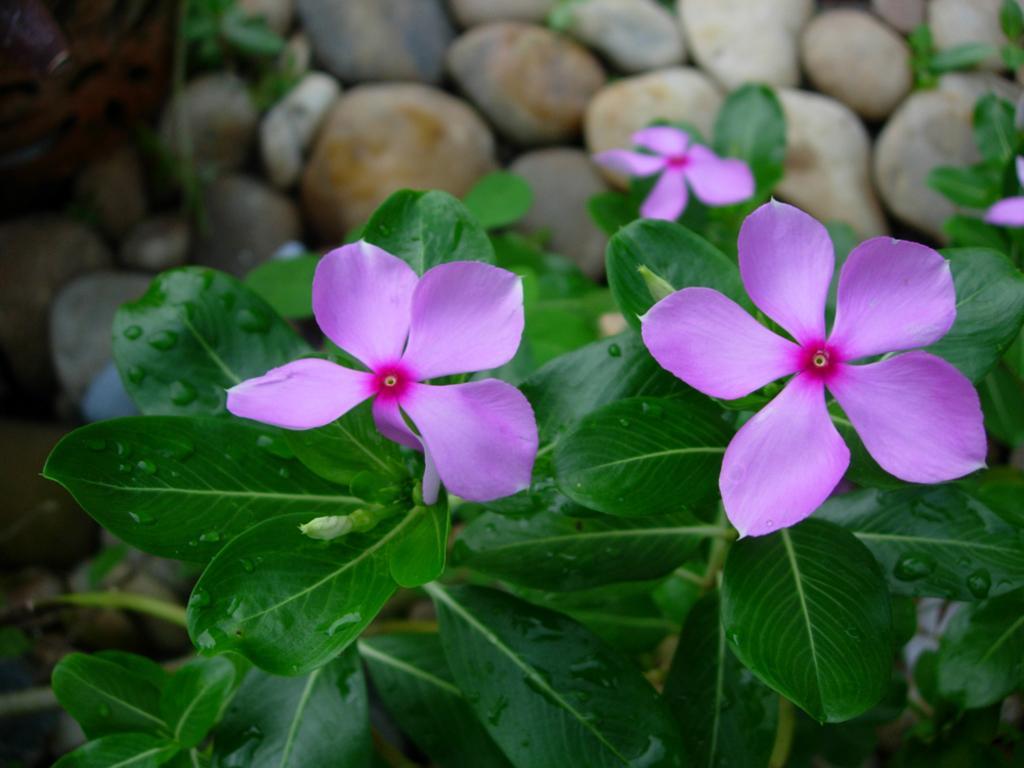Describe this image in one or two sentences. There are many rocks in the image. There are few plants in the image. We can see few flowers to the plants. 